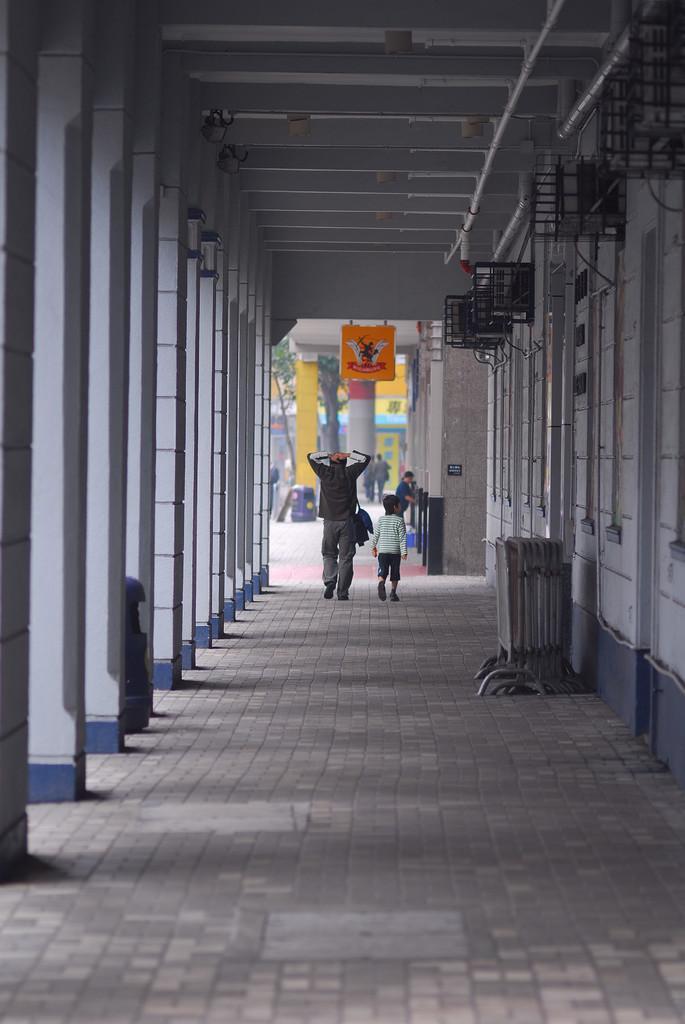Describe this image in one or two sentences. In this image there is a person walking on the floor. He is carrying a bag. Beside him there is a boy walking on the floor. There are people on the floor. Left side there are pillars attached to the roof. Right side there are objects attached to the wall. There are objects on the floor. There are trees. Behind there is a building. 